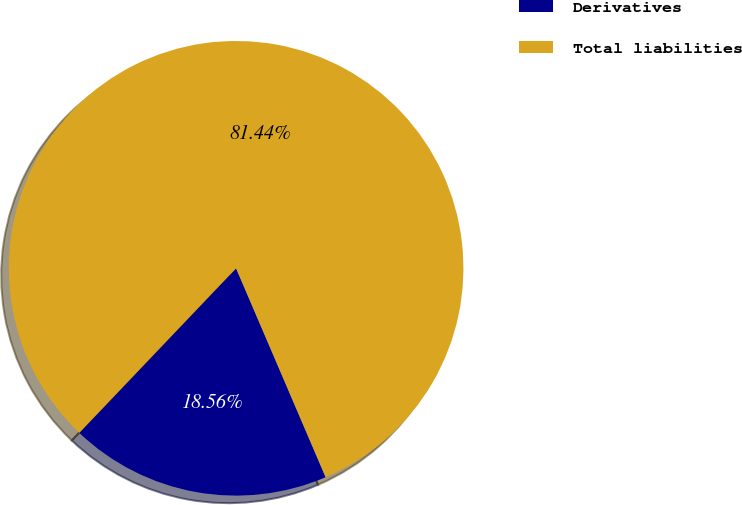Convert chart to OTSL. <chart><loc_0><loc_0><loc_500><loc_500><pie_chart><fcel>Derivatives<fcel>Total liabilities<nl><fcel>18.56%<fcel>81.44%<nl></chart> 